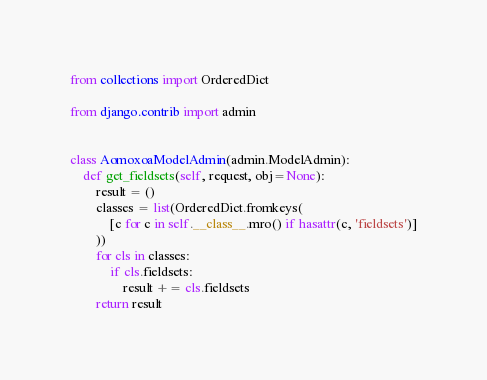<code> <loc_0><loc_0><loc_500><loc_500><_Python_>from collections import OrderedDict

from django.contrib import admin


class AomoxoaModelAdmin(admin.ModelAdmin):
    def get_fieldsets(self, request, obj=None):
        result = ()
        classes = list(OrderedDict.fromkeys(
            [c for c in self.__class__.mro() if hasattr(c, 'fieldsets')]
        ))
        for cls in classes:
            if cls.fieldsets:
                result += cls.fieldsets
        return result
</code> 